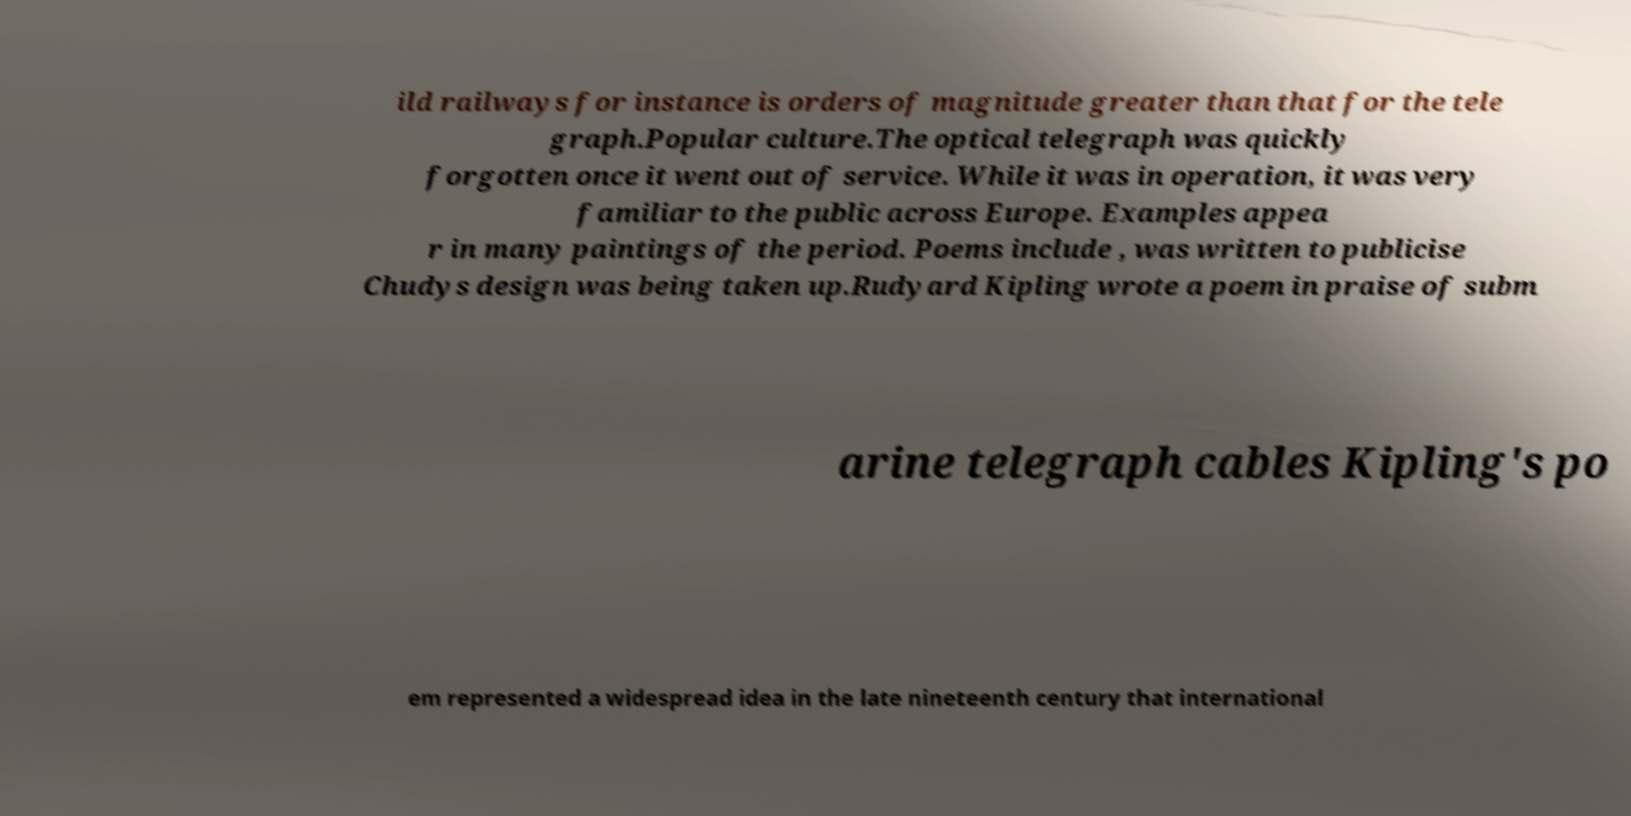Can you read and provide the text displayed in the image?This photo seems to have some interesting text. Can you extract and type it out for me? ild railways for instance is orders of magnitude greater than that for the tele graph.Popular culture.The optical telegraph was quickly forgotten once it went out of service. While it was in operation, it was very familiar to the public across Europe. Examples appea r in many paintings of the period. Poems include , was written to publicise Chudys design was being taken up.Rudyard Kipling wrote a poem in praise of subm arine telegraph cables Kipling's po em represented a widespread idea in the late nineteenth century that international 